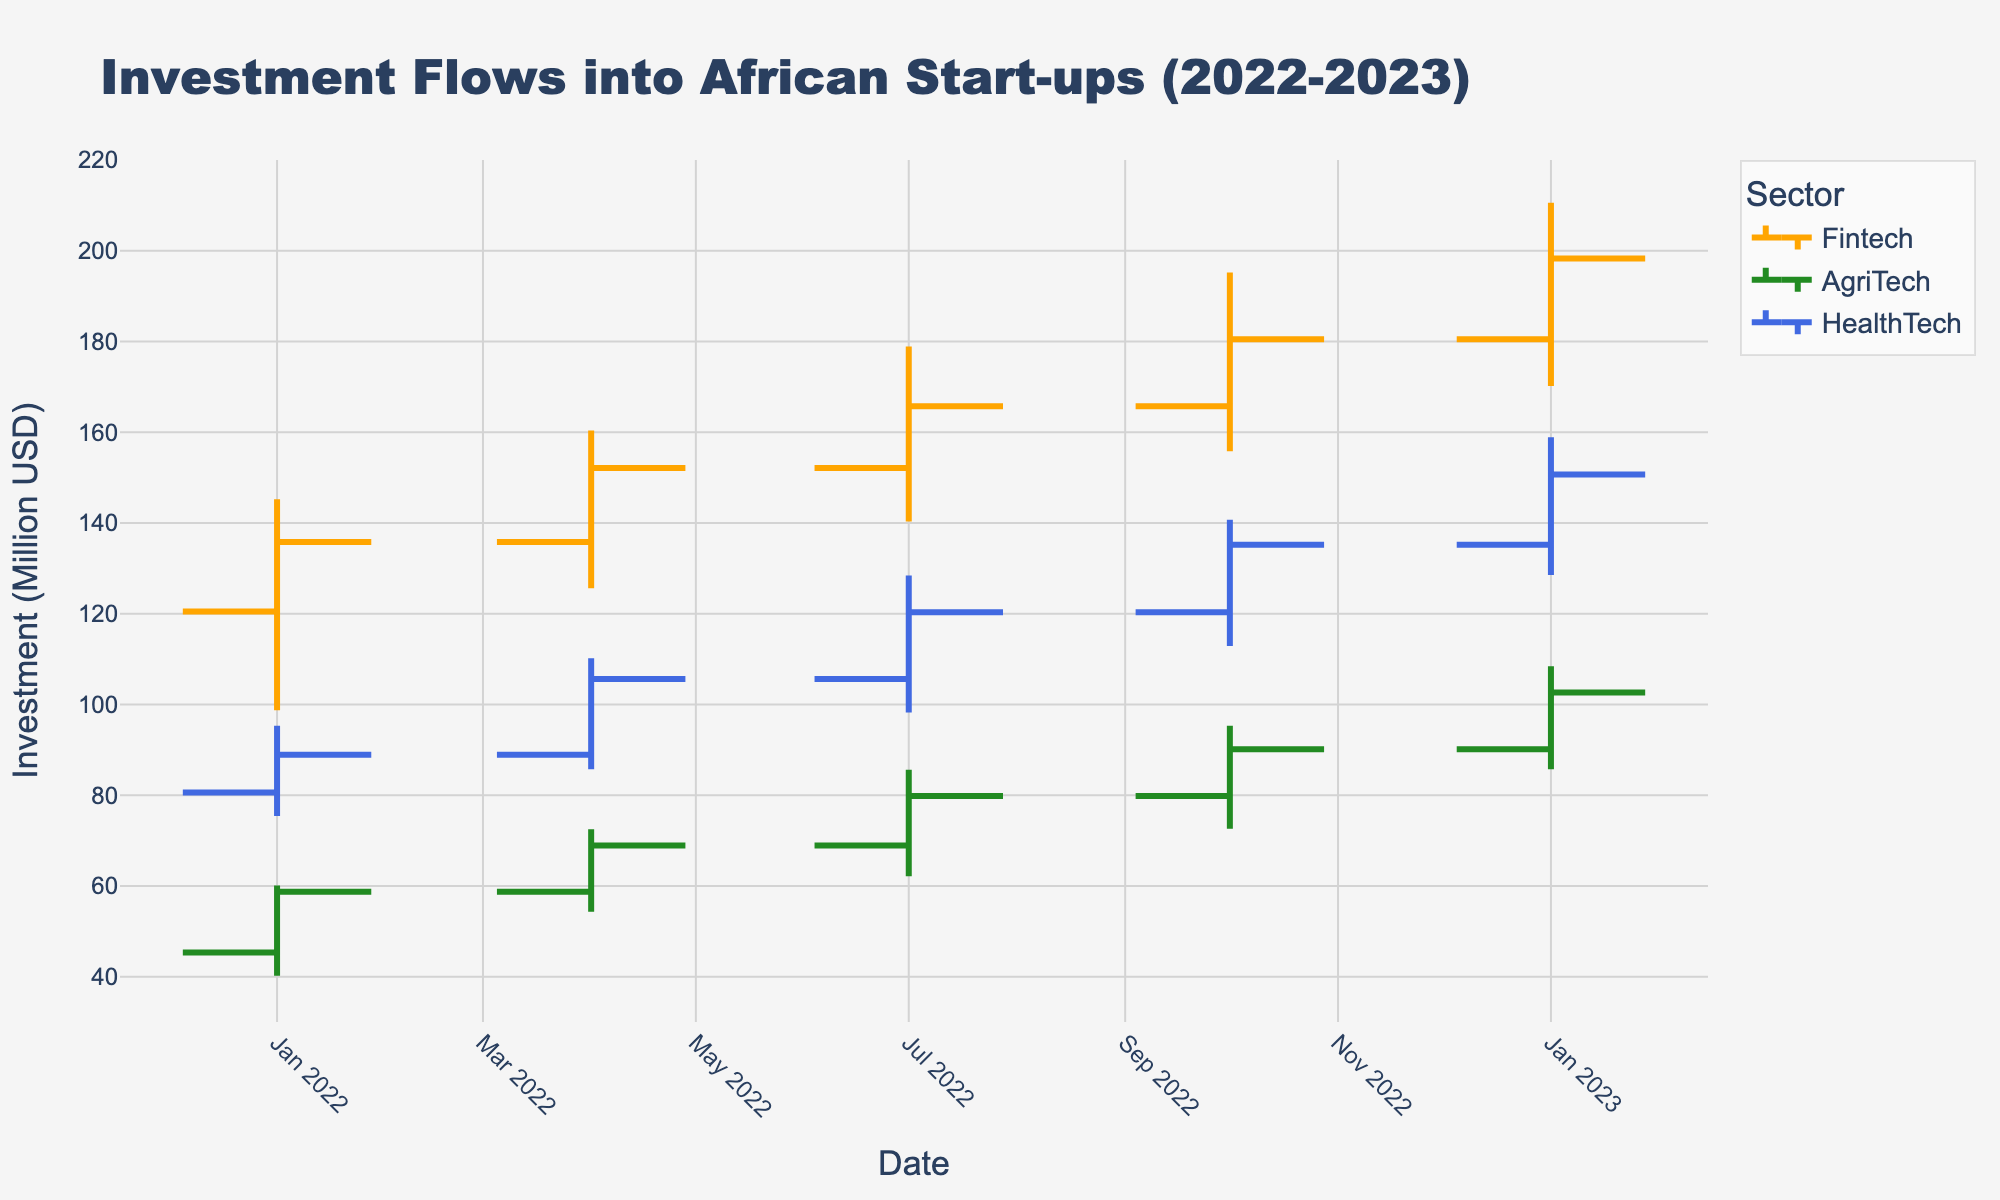What is the title of the figure? The title can be found at the top of the chart, usually displayed in a larger or bold font. Here, it reads "Investment Flows into African Start-ups (2022-2023)."
Answer: Investment Flows into African Start-ups (2022-2023) Which sector had the highest closing investment in 2023-Q1? To find this, look for the sector with the highest 'Close' value in 2023-Q1. The sectors are color-coded: Orange for Fintech, Green for AgriTech, and Blue for HealthTech.  Fintech had a closing investment of 198.3M, AgriTech had 102.6M, and HealthTech had 150.7M.
Answer: Fintech How many sectors are represented in the chart? Identify the unique sectors by looking at the labels of the lines in the legend. Three distinct sectors are represented.
Answer: 3 What was the closing investment for HealthTech in 2022-Q4? Refer to the blue line corresponding to HealthTech for the quarter 2022-Q4 and look at the 'Close' point, which is the endpoint of the vertical line. It is 135.2M.
Answer: 135.2M Which industry had the largest increase in investment from 2022-Q1 to 2023-Q1? Calculate the difference between the 'Close' value in 2023-Q1 and 'Open' value in 2022-Q1 for each sector. Fintech's increase is 198.3 - 120.5 = 77.8M. AgriTech's increase is 102.6 - 45.3 = 57.3M. HealthTech's increase is 150.7 - 80.6 = 70.1M. Fintech had the largest increase.
Answer: Fintech What is the trend for AgriTech investments from 2022-Q1 to 2023-Q1? Observe the green line representing AgriTech from 2022-Q1 to 2023-Q1. The 'Close' values show a consistent increase from 58.7M in 2022-Q1 to 102.6M in 2023-Q1.
Answer: Increasing Compare the highest investment values for Fintech and HealthTech in 2022-Q4. Which one is higher? Look at the 'High' values for both sectors in 2022-Q4. Fintech has a high of 195.2M, while HealthTech has a high of 140.7M. Fintech’s high value is greater.
Answer: Fintech What was the lowest investment value for AgriTech during the entire period shown? Identify the lowest value by checking the 'Low' values for AgriTech in all quarters. The lowest value is 40.2M in 2022-Q1.
Answer: 40.2M 